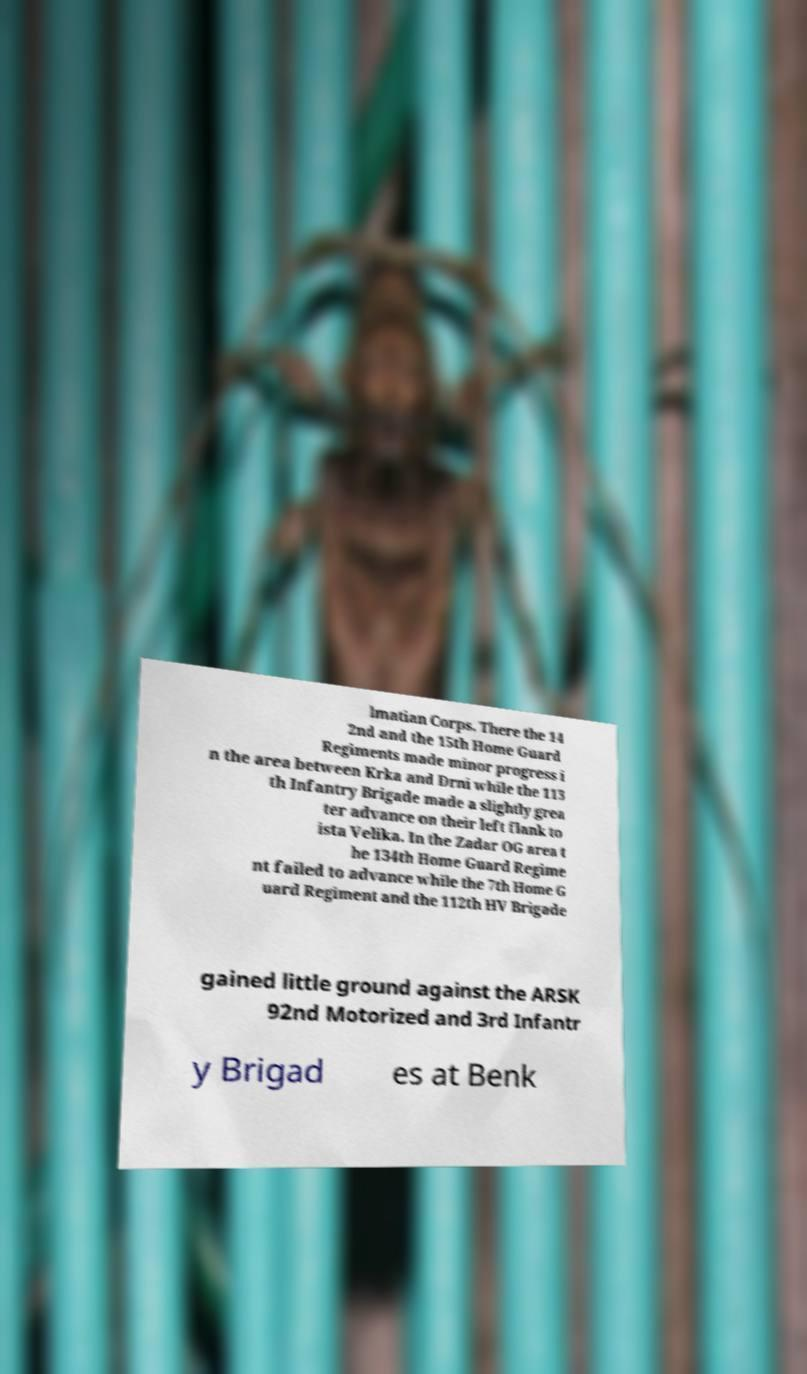For documentation purposes, I need the text within this image transcribed. Could you provide that? lmatian Corps. There the 14 2nd and the 15th Home Guard Regiments made minor progress i n the area between Krka and Drni while the 113 th Infantry Brigade made a slightly grea ter advance on their left flank to ista Velika. In the Zadar OG area t he 134th Home Guard Regime nt failed to advance while the 7th Home G uard Regiment and the 112th HV Brigade gained little ground against the ARSK 92nd Motorized and 3rd Infantr y Brigad es at Benk 